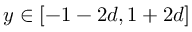Convert formula to latex. <formula><loc_0><loc_0><loc_500><loc_500>y \in [ - 1 - 2 d , 1 + 2 d ]</formula> 